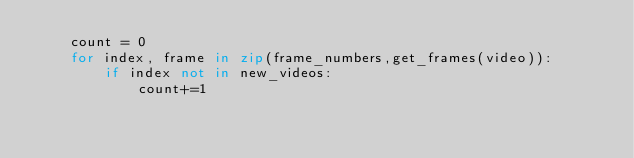<code> <loc_0><loc_0><loc_500><loc_500><_Python_>    count = 0
    for index, frame in zip(frame_numbers,get_frames(video)):
        if index not in new_videos:
            count+=1</code> 